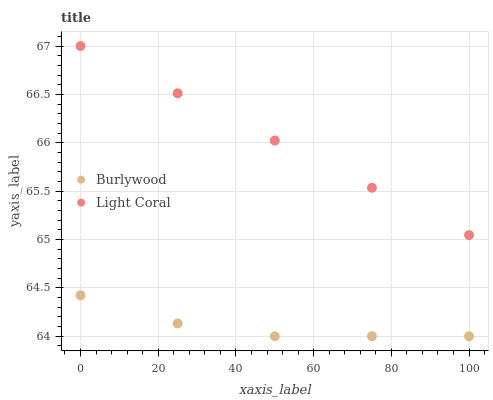Does Burlywood have the minimum area under the curve?
Answer yes or no. Yes. Does Light Coral have the maximum area under the curve?
Answer yes or no. Yes. Does Light Coral have the minimum area under the curve?
Answer yes or no. No. Is Light Coral the smoothest?
Answer yes or no. Yes. Is Burlywood the roughest?
Answer yes or no. Yes. Is Light Coral the roughest?
Answer yes or no. No. Does Burlywood have the lowest value?
Answer yes or no. Yes. Does Light Coral have the lowest value?
Answer yes or no. No. Does Light Coral have the highest value?
Answer yes or no. Yes. Is Burlywood less than Light Coral?
Answer yes or no. Yes. Is Light Coral greater than Burlywood?
Answer yes or no. Yes. Does Burlywood intersect Light Coral?
Answer yes or no. No. 